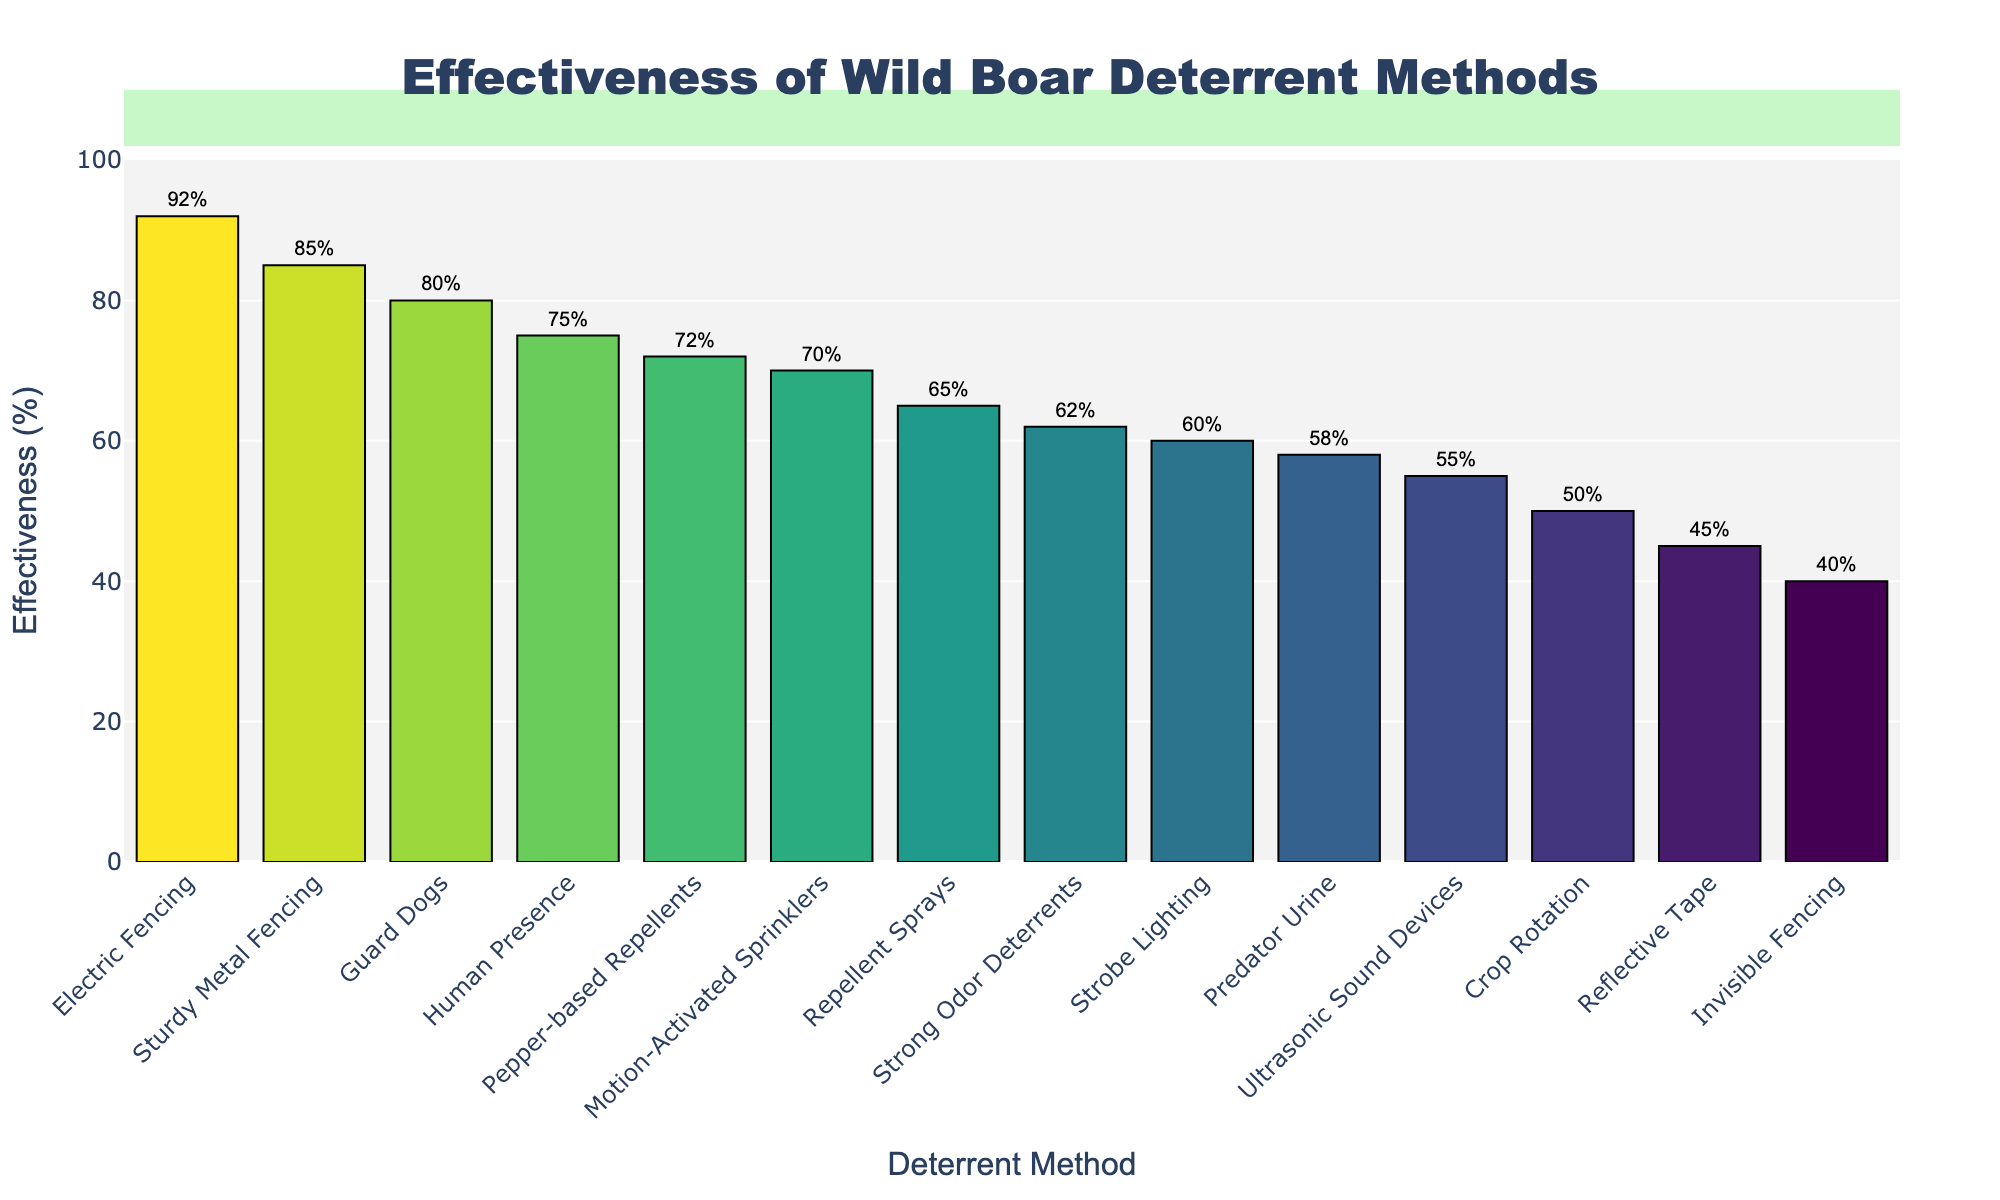What is the most effective deterrent method against wild boars? Observe the highest bar in the bar chart to determine the method with the highest effectiveness percentage. The Electric Fencing method has the highest bar with an effectiveness of 92%.
Answer: Electric Fencing Which method has a higher effectiveness: Ultrasonic Sound Devices or Strobe Lighting? Compare the heights of the bars corresponding to Ultrasonic Sound Devices and Strobe Lighting. Ultrasonic Sound Devices have an effectiveness of 55%, while Strobe Lighting has an effectiveness of 60%.
Answer: Strobe Lighting What's the effectiveness percentage difference between Guard Dogs and Predator Urine? Compare the effectiveness percentages of Guard Dogs (80%) and Predator Urine (58%), then subtract the lower value from the higher value: 80% - 58% = 22%.
Answer: 22% How does the effectiveness of Repellent Sprays compare with Motion-Activated Sprinklers? Compare the heights of the bars for Repellent Sprays and Motion-Activated Sprinklers. Repellent Sprays have an effectiveness of 65%, while Motion-Activated Sprinklers have 70%.
Answer: Motion-Activated Sprinklers Which deterrent methods have an effectiveness percentage below 50%? Scan the graph to identify bars with effectiveness percentages less than 50%: Reflective Tape (45%), Predator Urine (58%), and Invisible Fencing (40%) are the relevant methods.
Answer: Reflective Tape, Invisible Fencing What is the average effectiveness of the top 3 most effective methods? Identify the top 3 methods: Electric Fencing (92%), Sturdy Metal Fencing (85%), and Guard Dogs (80%). Calculate the average: (92 + 85 + 80) / 3 = 85.67.
Answer: 85.67 By how much does the effectiveness of Human Presence exceed that of Crop Rotation? Compare the effectiveness of Human Presence (75%) and Crop Rotation (50%), then subtract the lower value from the higher value: 75% - 50% = 25%.
Answer: 25% Which methods have an effectiveness percentage of 60% or above but less than 75%? Identify the bars with effectiveness values ≥60% but <75%. These methods are Strobe Lighting (60%), Pepper-based Repellents (72%), Repellent Sprays (65%), and Motion-Activated Sprinklers (70%).
Answer: Strobe Lighting, Pepper-based Repellents, Repellent Sprays, Motion-Activated Sprinklers What is the median effectiveness value of all the deterrent methods? List all effectiveness values and find the median: 92, 85, 80, 75, 72, 70, 65, 62, 60, 58, 55, 50, 45, 40. The median value, being the middle number in a sorted list of 14 elements, is the average of the 7th and 8th values: (65 + 62) / 2 = 63.5.
Answer: 63.5 Which deterrent method is less effective than Predator Urine but more effective than Crop Rotation? Compare the effectiveness of Predator Urine (58%) and Crop Rotation (50%), then find the method that falls in between these values. The effectiveness of Reflective Tape is 45% (too low), and none other fit within the specified range. There is no such method.
Answer: None 